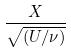<formula> <loc_0><loc_0><loc_500><loc_500>\frac { X } { \sqrt { ( U / \nu ) } }</formula> 